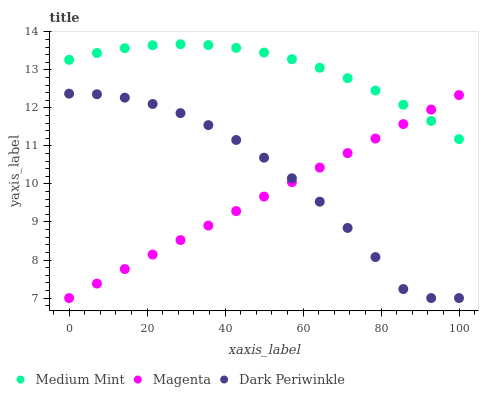Does Magenta have the minimum area under the curve?
Answer yes or no. Yes. Does Medium Mint have the maximum area under the curve?
Answer yes or no. Yes. Does Dark Periwinkle have the minimum area under the curve?
Answer yes or no. No. Does Dark Periwinkle have the maximum area under the curve?
Answer yes or no. No. Is Magenta the smoothest?
Answer yes or no. Yes. Is Dark Periwinkle the roughest?
Answer yes or no. Yes. Is Dark Periwinkle the smoothest?
Answer yes or no. No. Is Magenta the roughest?
Answer yes or no. No. Does Magenta have the lowest value?
Answer yes or no. Yes. Does Medium Mint have the highest value?
Answer yes or no. Yes. Does Dark Periwinkle have the highest value?
Answer yes or no. No. Is Dark Periwinkle less than Medium Mint?
Answer yes or no. Yes. Is Medium Mint greater than Dark Periwinkle?
Answer yes or no. Yes. Does Magenta intersect Medium Mint?
Answer yes or no. Yes. Is Magenta less than Medium Mint?
Answer yes or no. No. Is Magenta greater than Medium Mint?
Answer yes or no. No. Does Dark Periwinkle intersect Medium Mint?
Answer yes or no. No. 